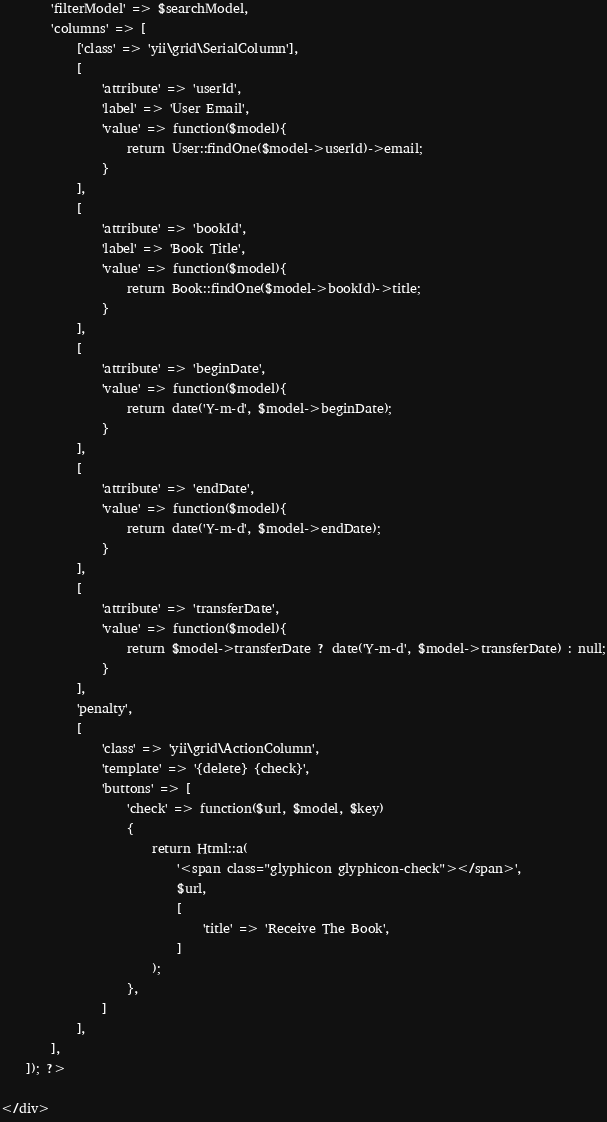Convert code to text. <code><loc_0><loc_0><loc_500><loc_500><_PHP_>        'filterModel' => $searchModel,
        'columns' => [
            ['class' => 'yii\grid\SerialColumn'],
            [
                'attribute' => 'userId',
                'label' => 'User Email',
                'value' => function($model){
                    return User::findOne($model->userId)->email;
                }
            ],
            [
                'attribute' => 'bookId',
                'label' => 'Book Title',
                'value' => function($model){
                    return Book::findOne($model->bookId)->title;
                }
            ],
            [
                'attribute' => 'beginDate',
                'value' => function($model){
                    return date('Y-m-d', $model->beginDate);
                }
            ],
            [
                'attribute' => 'endDate',
                'value' => function($model){
                    return date('Y-m-d', $model->endDate);
                }
            ],
            [
                'attribute' => 'transferDate',
                'value' => function($model){
                    return $model->transferDate ? date('Y-m-d', $model->transferDate) : null;
                }
            ],
            'penalty',
            [
                'class' => 'yii\grid\ActionColumn',
                'template' => '{delete} {check}',
                'buttons' => [
                    'check' => function($url, $model, $key)
                    {
                        return Html::a(
                            '<span class="glyphicon glyphicon-check"></span>',
                            $url,
                            [
                                'title' => 'Receive The Book',
                            ]
                        );
                    },
                ]
            ],
        ],
    ]); ?>

</div>
</code> 